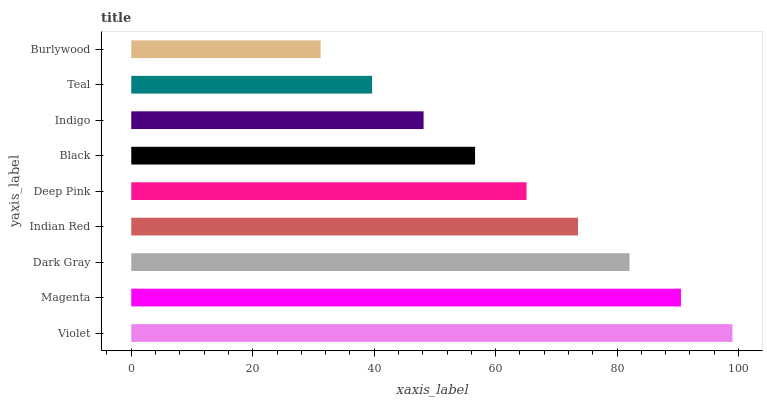Is Burlywood the minimum?
Answer yes or no. Yes. Is Violet the maximum?
Answer yes or no. Yes. Is Magenta the minimum?
Answer yes or no. No. Is Magenta the maximum?
Answer yes or no. No. Is Violet greater than Magenta?
Answer yes or no. Yes. Is Magenta less than Violet?
Answer yes or no. Yes. Is Magenta greater than Violet?
Answer yes or no. No. Is Violet less than Magenta?
Answer yes or no. No. Is Deep Pink the high median?
Answer yes or no. Yes. Is Deep Pink the low median?
Answer yes or no. Yes. Is Indigo the high median?
Answer yes or no. No. Is Violet the low median?
Answer yes or no. No. 